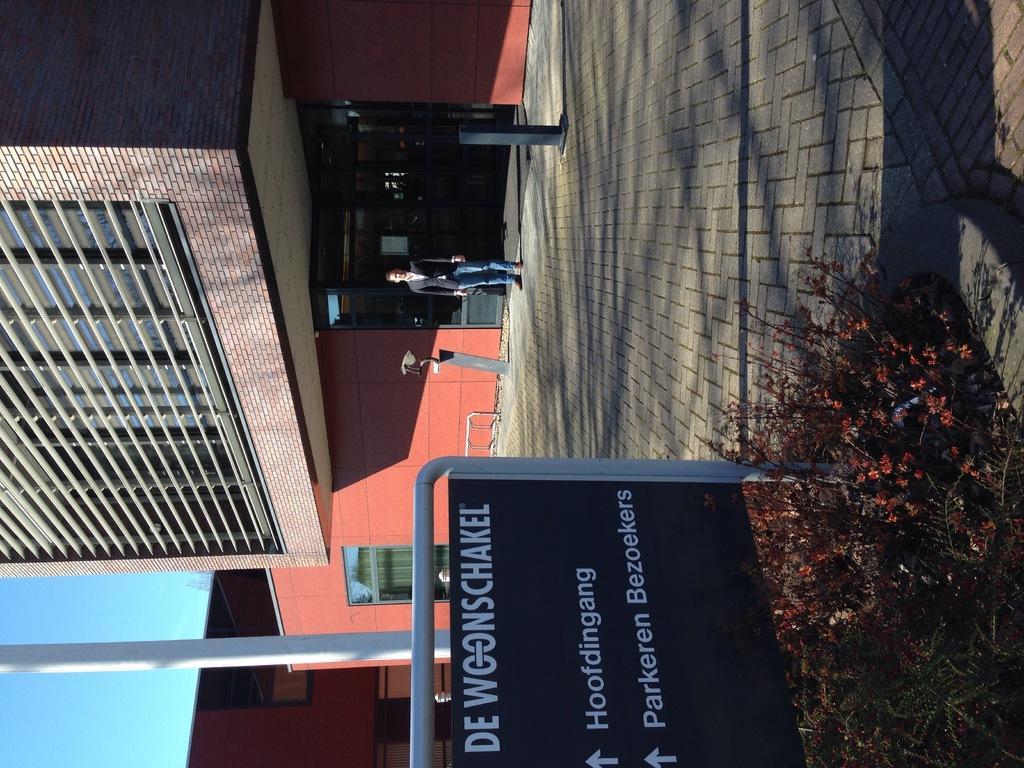In one or two sentences, can you explain what this image depicts? In this picture there is a man who is wearing blazer, shirt, jeans and shoe. He is standing near to the black poles. At the bottom there is a sign board, beside that I can see a some flowers on the plants. In the background I can see the building. In the bottom left corner there is a sky. 